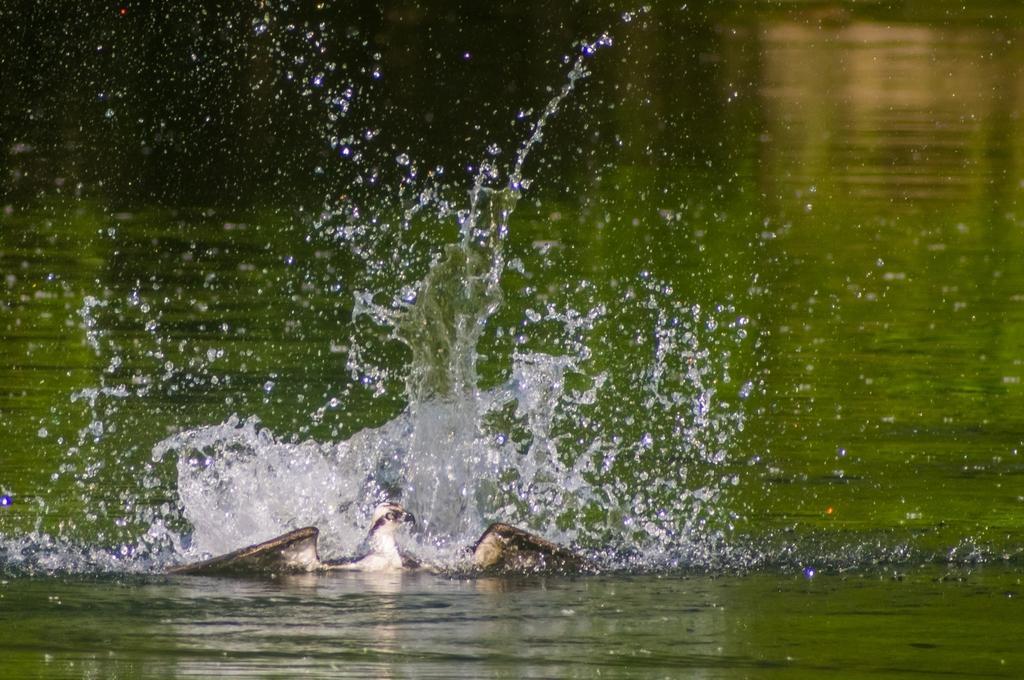In one or two sentences, can you explain what this image depicts? In this picture we can observe a bird in the water. This bird is in white and brown color. In the background we can observe a pond. 